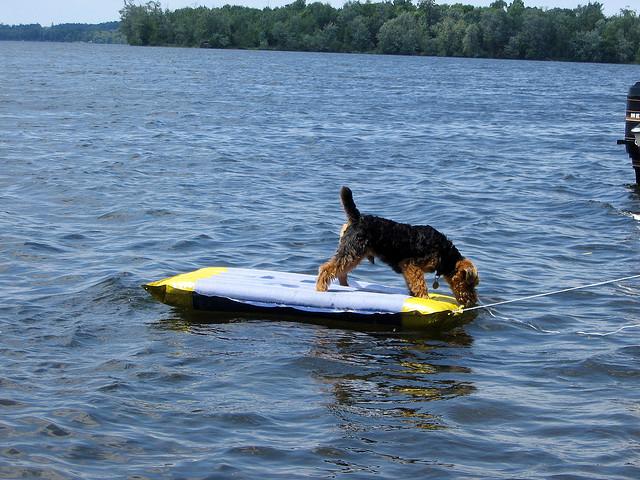Is the raft moving fast?
Quick response, please. No. Where is the dog standing?
Write a very short answer. Raft. How is the wakeboard moved through the water?
Quick response, please. Rope. What is in his mouth?
Be succinct. Water. Is this dog a German Shepherd?
Give a very brief answer. No. 